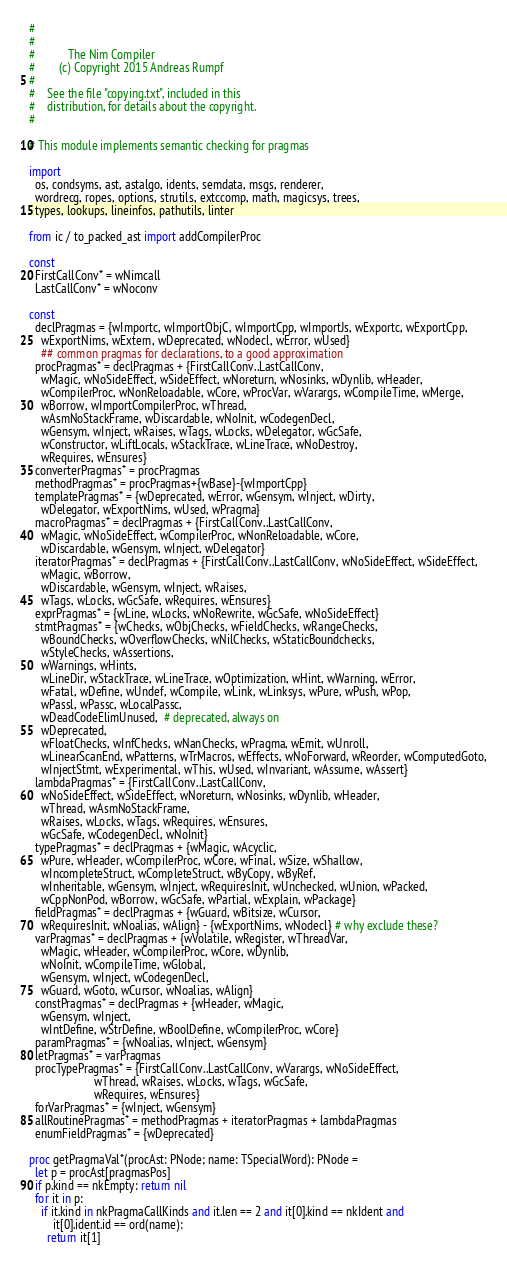<code> <loc_0><loc_0><loc_500><loc_500><_Nim_>#
#
#           The Nim Compiler
#        (c) Copyright 2015 Andreas Rumpf
#
#    See the file "copying.txt", included in this
#    distribution, for details about the copyright.
#

# This module implements semantic checking for pragmas

import
  os, condsyms, ast, astalgo, idents, semdata, msgs, renderer,
  wordrecg, ropes, options, strutils, extccomp, math, magicsys, trees,
  types, lookups, lineinfos, pathutils, linter

from ic / to_packed_ast import addCompilerProc

const
  FirstCallConv* = wNimcall
  LastCallConv* = wNoconv

const
  declPragmas = {wImportc, wImportObjC, wImportCpp, wImportJs, wExportc, wExportCpp,
    wExportNims, wExtern, wDeprecated, wNodecl, wError, wUsed}
    ## common pragmas for declarations, to a good approximation
  procPragmas* = declPragmas + {FirstCallConv..LastCallConv,
    wMagic, wNoSideEffect, wSideEffect, wNoreturn, wNosinks, wDynlib, wHeader,
    wCompilerProc, wNonReloadable, wCore, wProcVar, wVarargs, wCompileTime, wMerge,
    wBorrow, wImportCompilerProc, wThread,
    wAsmNoStackFrame, wDiscardable, wNoInit, wCodegenDecl,
    wGensym, wInject, wRaises, wTags, wLocks, wDelegator, wGcSafe,
    wConstructor, wLiftLocals, wStackTrace, wLineTrace, wNoDestroy,
    wRequires, wEnsures}
  converterPragmas* = procPragmas
  methodPragmas* = procPragmas+{wBase}-{wImportCpp}
  templatePragmas* = {wDeprecated, wError, wGensym, wInject, wDirty,
    wDelegator, wExportNims, wUsed, wPragma}
  macroPragmas* = declPragmas + {FirstCallConv..LastCallConv,
    wMagic, wNoSideEffect, wCompilerProc, wNonReloadable, wCore,
    wDiscardable, wGensym, wInject, wDelegator}
  iteratorPragmas* = declPragmas + {FirstCallConv..LastCallConv, wNoSideEffect, wSideEffect,
    wMagic, wBorrow,
    wDiscardable, wGensym, wInject, wRaises,
    wTags, wLocks, wGcSafe, wRequires, wEnsures}
  exprPragmas* = {wLine, wLocks, wNoRewrite, wGcSafe, wNoSideEffect}
  stmtPragmas* = {wChecks, wObjChecks, wFieldChecks, wRangeChecks,
    wBoundChecks, wOverflowChecks, wNilChecks, wStaticBoundchecks,
    wStyleChecks, wAssertions,
    wWarnings, wHints,
    wLineDir, wStackTrace, wLineTrace, wOptimization, wHint, wWarning, wError,
    wFatal, wDefine, wUndef, wCompile, wLink, wLinksys, wPure, wPush, wPop,
    wPassl, wPassc, wLocalPassc,
    wDeadCodeElimUnused,  # deprecated, always on
    wDeprecated,
    wFloatChecks, wInfChecks, wNanChecks, wPragma, wEmit, wUnroll,
    wLinearScanEnd, wPatterns, wTrMacros, wEffects, wNoForward, wReorder, wComputedGoto,
    wInjectStmt, wExperimental, wThis, wUsed, wInvariant, wAssume, wAssert}
  lambdaPragmas* = {FirstCallConv..LastCallConv,
    wNoSideEffect, wSideEffect, wNoreturn, wNosinks, wDynlib, wHeader,
    wThread, wAsmNoStackFrame,
    wRaises, wLocks, wTags, wRequires, wEnsures,
    wGcSafe, wCodegenDecl, wNoInit}
  typePragmas* = declPragmas + {wMagic, wAcyclic,
    wPure, wHeader, wCompilerProc, wCore, wFinal, wSize, wShallow,
    wIncompleteStruct, wCompleteStruct, wByCopy, wByRef,
    wInheritable, wGensym, wInject, wRequiresInit, wUnchecked, wUnion, wPacked,
    wCppNonPod, wBorrow, wGcSafe, wPartial, wExplain, wPackage}
  fieldPragmas* = declPragmas + {wGuard, wBitsize, wCursor,
    wRequiresInit, wNoalias, wAlign} - {wExportNims, wNodecl} # why exclude these?
  varPragmas* = declPragmas + {wVolatile, wRegister, wThreadVar,
    wMagic, wHeader, wCompilerProc, wCore, wDynlib,
    wNoInit, wCompileTime, wGlobal,
    wGensym, wInject, wCodegenDecl,
    wGuard, wGoto, wCursor, wNoalias, wAlign}
  constPragmas* = declPragmas + {wHeader, wMagic,
    wGensym, wInject,
    wIntDefine, wStrDefine, wBoolDefine, wCompilerProc, wCore}
  paramPragmas* = {wNoalias, wInject, wGensym}
  letPragmas* = varPragmas
  procTypePragmas* = {FirstCallConv..LastCallConv, wVarargs, wNoSideEffect,
                      wThread, wRaises, wLocks, wTags, wGcSafe,
                      wRequires, wEnsures}
  forVarPragmas* = {wInject, wGensym}
  allRoutinePragmas* = methodPragmas + iteratorPragmas + lambdaPragmas
  enumFieldPragmas* = {wDeprecated}

proc getPragmaVal*(procAst: PNode; name: TSpecialWord): PNode =
  let p = procAst[pragmasPos]
  if p.kind == nkEmpty: return nil
  for it in p:
    if it.kind in nkPragmaCallKinds and it.len == 2 and it[0].kind == nkIdent and
        it[0].ident.id == ord(name):
      return it[1]
</code> 